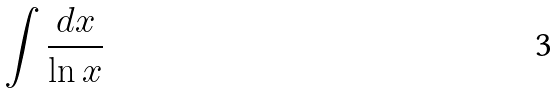Convert formula to latex. <formula><loc_0><loc_0><loc_500><loc_500>\int \frac { d x } { \ln x }</formula> 